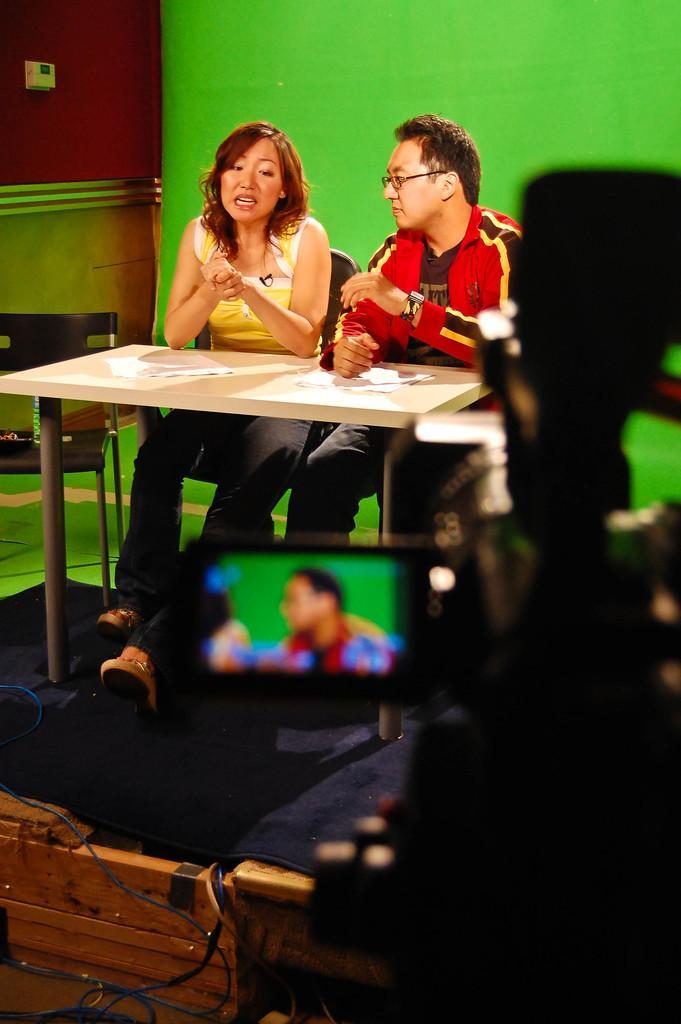Can you describe this image briefly? This picture is taken in a room. There are two persons, one woman and one man. There are sitting on chairs and leaning to a table. She is wearing a yellow top and black trousers. He is wearing a red shirt and black trousers. Behind them there is a green mat. To the right corner there is a camera shooting them. 